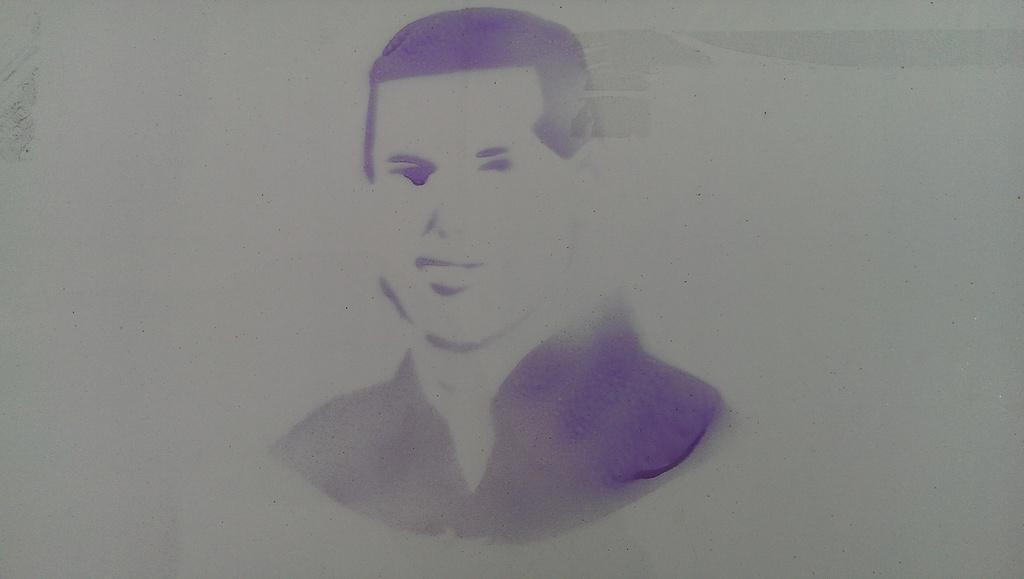What is the main subject of the image? There is a painting in the image. What is depicted in the painting? The painting depicts a person. What color is the person wearing in the painting? The person in the painting is wearing violet color. What is the color of the background in the painting? The background of the painting is white in color. How does the person in the painting join the group of people in the image? There is no group of people in the image, only the painting of a person. What type of hook is used by the person in the painting? There is no hook present in the painting; the person is wearing violet clothing. 